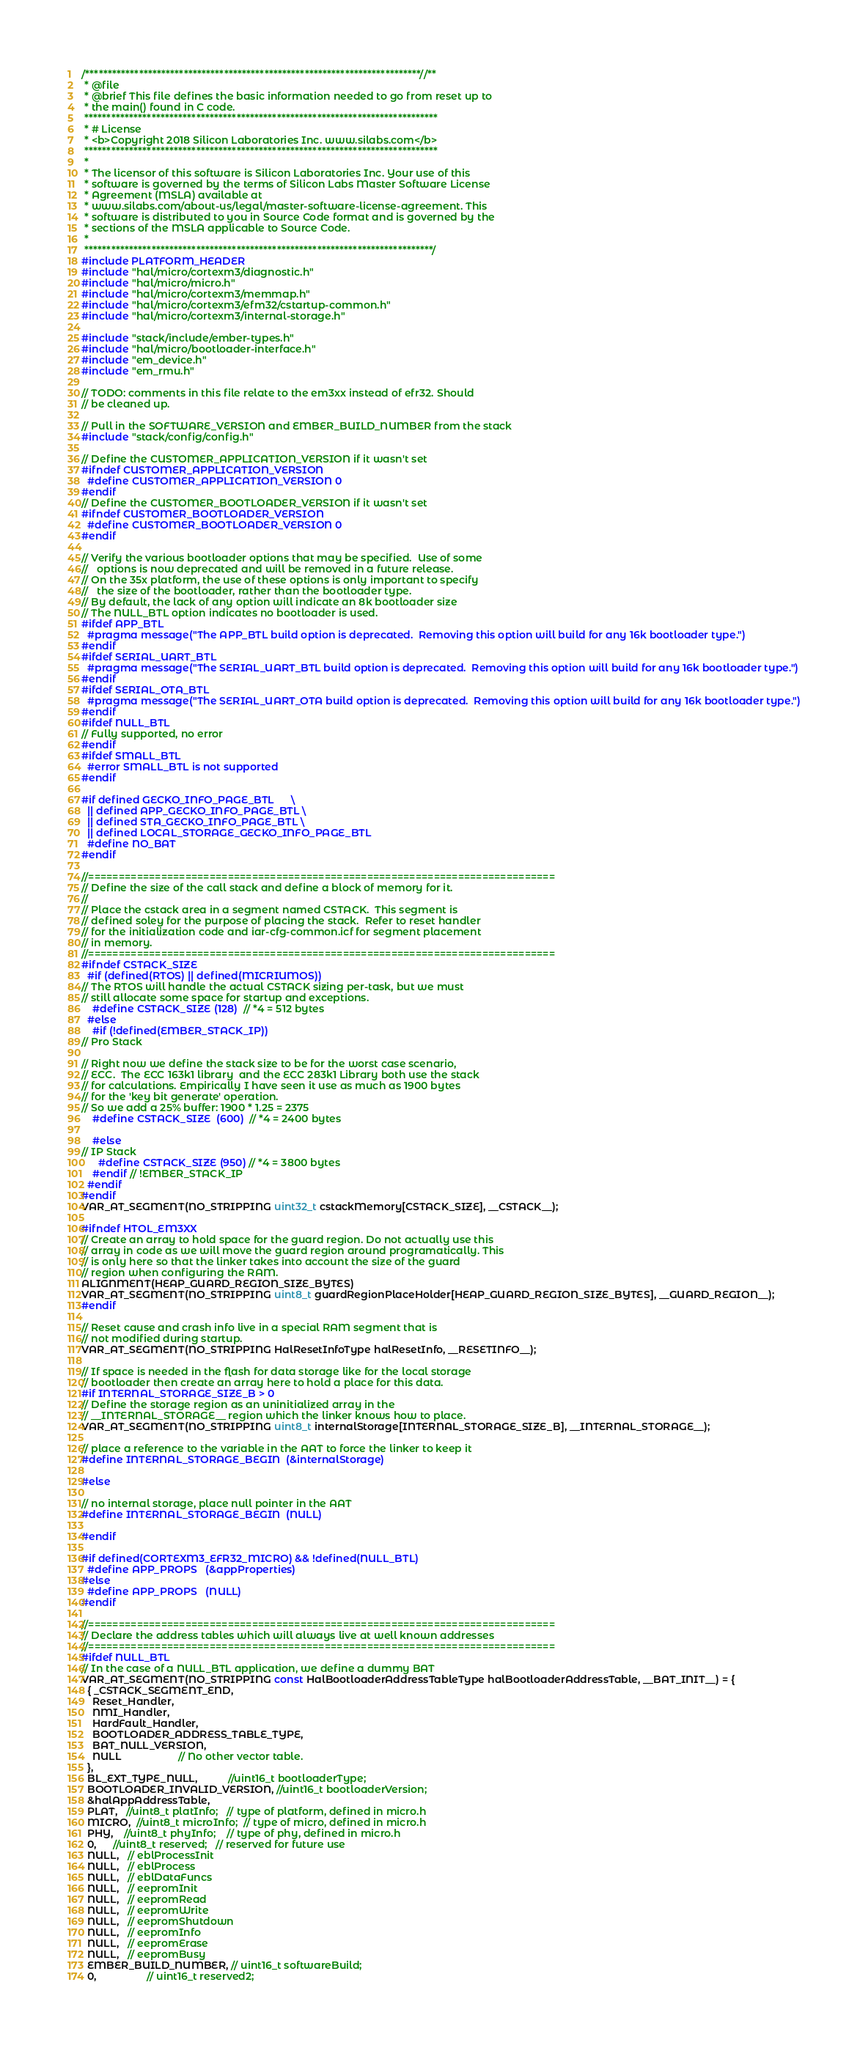<code> <loc_0><loc_0><loc_500><loc_500><_C_>/***************************************************************************//**
 * @file
 * @brief This file defines the basic information needed to go from reset up to
 * the main() found in C code.
 *******************************************************************************
 * # License
 * <b>Copyright 2018 Silicon Laboratories Inc. www.silabs.com</b>
 *******************************************************************************
 *
 * The licensor of this software is Silicon Laboratories Inc. Your use of this
 * software is governed by the terms of Silicon Labs Master Software License
 * Agreement (MSLA) available at
 * www.silabs.com/about-us/legal/master-software-license-agreement. This
 * software is distributed to you in Source Code format and is governed by the
 * sections of the MSLA applicable to Source Code.
 *
 ******************************************************************************/
#include PLATFORM_HEADER
#include "hal/micro/cortexm3/diagnostic.h"
#include "hal/micro/micro.h"
#include "hal/micro/cortexm3/memmap.h"
#include "hal/micro/cortexm3/efm32/cstartup-common.h"
#include "hal/micro/cortexm3/internal-storage.h"

#include "stack/include/ember-types.h"
#include "hal/micro/bootloader-interface.h"
#include "em_device.h"
#include "em_rmu.h"

// TODO: comments in this file relate to the em3xx instead of efr32. Should
// be cleaned up.

// Pull in the SOFTWARE_VERSION and EMBER_BUILD_NUMBER from the stack
#include "stack/config/config.h"

// Define the CUSTOMER_APPLICATION_VERSION if it wasn't set
#ifndef CUSTOMER_APPLICATION_VERSION
  #define CUSTOMER_APPLICATION_VERSION 0
#endif
// Define the CUSTOMER_BOOTLOADER_VERSION if it wasn't set
#ifndef CUSTOMER_BOOTLOADER_VERSION
  #define CUSTOMER_BOOTLOADER_VERSION 0
#endif

// Verify the various bootloader options that may be specified.  Use of some
//   options is now deprecated and will be removed in a future release.
// On the 35x platform, the use of these options is only important to specify
//   the size of the bootloader, rather than the bootloader type.
// By default, the lack of any option will indicate an 8k bootloader size
// The NULL_BTL option indicates no bootloader is used.
#ifdef APP_BTL
  #pragma message("The APP_BTL build option is deprecated.  Removing this option will build for any 16k bootloader type.")
#endif
#ifdef SERIAL_UART_BTL
  #pragma message("The SERIAL_UART_BTL build option is deprecated.  Removing this option will build for any 16k bootloader type.")
#endif
#ifdef SERIAL_OTA_BTL
  #pragma message("The SERIAL_UART_OTA build option is deprecated.  Removing this option will build for any 16k bootloader type.")
#endif
#ifdef NULL_BTL
// Fully supported, no error
#endif
#ifdef SMALL_BTL
  #error SMALL_BTL is not supported
#endif

#if defined GECKO_INFO_PAGE_BTL      \
  || defined APP_GECKO_INFO_PAGE_BTL \
  || defined STA_GECKO_INFO_PAGE_BTL \
  || defined LOCAL_STORAGE_GECKO_INFO_PAGE_BTL
  #define NO_BAT
#endif

//=============================================================================
// Define the size of the call stack and define a block of memory for it.
//
// Place the cstack area in a segment named CSTACK.  This segment is
// defined soley for the purpose of placing the stack.  Refer to reset handler
// for the initialization code and iar-cfg-common.icf for segment placement
// in memory.
//=============================================================================
#ifndef CSTACK_SIZE
  #if (defined(RTOS) || defined(MICRIUMOS))
// The RTOS will handle the actual CSTACK sizing per-task, but we must
// still allocate some space for startup and exceptions.
    #define CSTACK_SIZE (128)  // *4 = 512 bytes
  #else
    #if (!defined(EMBER_STACK_IP))
// Pro Stack

// Right now we define the stack size to be for the worst case scenario,
// ECC.  The ECC 163k1 library  and the ECC 283k1 Library both use the stack
// for calculations. Empirically I have seen it use as much as 1900 bytes
// for the 'key bit generate' operation.
// So we add a 25% buffer: 1900 * 1.25 = 2375
    #define CSTACK_SIZE  (600)  // *4 = 2400 bytes

    #else
// IP Stack
      #define CSTACK_SIZE (950) // *4 = 3800 bytes
    #endif // !EMBER_STACK_IP
  #endif
#endif
VAR_AT_SEGMENT(NO_STRIPPING uint32_t cstackMemory[CSTACK_SIZE], __CSTACK__);

#ifndef HTOL_EM3XX
// Create an array to hold space for the guard region. Do not actually use this
// array in code as we will move the guard region around programatically. This
// is only here so that the linker takes into account the size of the guard
// region when configuring the RAM.
ALIGNMENT(HEAP_GUARD_REGION_SIZE_BYTES)
VAR_AT_SEGMENT(NO_STRIPPING uint8_t guardRegionPlaceHolder[HEAP_GUARD_REGION_SIZE_BYTES], __GUARD_REGION__);
#endif

// Reset cause and crash info live in a special RAM segment that is
// not modified during startup.
VAR_AT_SEGMENT(NO_STRIPPING HalResetInfoType halResetInfo, __RESETINFO__);

// If space is needed in the flash for data storage like for the local storage
// bootloader then create an array here to hold a place for this data.
#if INTERNAL_STORAGE_SIZE_B > 0
// Define the storage region as an uninitialized array in the
// __INTERNAL_STORAGE__ region which the linker knows how to place.
VAR_AT_SEGMENT(NO_STRIPPING uint8_t internalStorage[INTERNAL_STORAGE_SIZE_B], __INTERNAL_STORAGE__);

// place a reference to the variable in the AAT to force the linker to keep it
#define INTERNAL_STORAGE_BEGIN  (&internalStorage)

#else

// no internal storage, place null pointer in the AAT
#define INTERNAL_STORAGE_BEGIN  (NULL)

#endif

#if defined(CORTEXM3_EFR32_MICRO) && !defined(NULL_BTL)
  #define APP_PROPS   (&appProperties)
#else
  #define APP_PROPS   (NULL)
#endif

//=============================================================================
// Declare the address tables which will always live at well known addresses
//=============================================================================
#ifdef NULL_BTL
// In the case of a NULL_BTL application, we define a dummy BAT
VAR_AT_SEGMENT(NO_STRIPPING const HalBootloaderAddressTableType halBootloaderAddressTable, __BAT_INIT__) = {
  { _CSTACK_SEGMENT_END,
    Reset_Handler,
    NMI_Handler,
    HardFault_Handler,
    BOOTLOADER_ADDRESS_TABLE_TYPE,
    BAT_NULL_VERSION,
    NULL                    // No other vector table.
  },
  BL_EXT_TYPE_NULL,           //uint16_t bootloaderType;
  BOOTLOADER_INVALID_VERSION, //uint16_t bootloaderVersion;
  &halAppAddressTable,
  PLAT,   //uint8_t platInfo;   // type of platform, defined in micro.h
  MICRO,  //uint8_t microInfo;  // type of micro, defined in micro.h
  PHY,    //uint8_t phyInfo;    // type of phy, defined in micro.h
  0,      //uint8_t reserved;   // reserved for future use
  NULL,   // eblProcessInit
  NULL,   // eblProcess
  NULL,   // eblDataFuncs
  NULL,   // eepromInit
  NULL,   // eepromRead
  NULL,   // eepromWrite
  NULL,   // eepromShutdown
  NULL,   // eepromInfo
  NULL,   // eepromErase
  NULL,   // eepromBusy
  EMBER_BUILD_NUMBER, // uint16_t softwareBuild;
  0,                  // uint16_t reserved2;</code> 